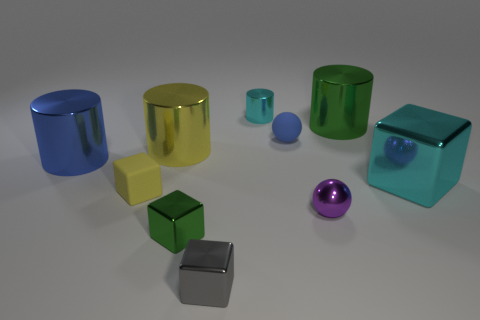Do the big blue thing and the green thing to the right of the cyan metal cylinder have the same material?
Make the answer very short. Yes. Are there more blue things right of the large cyan block than small blue matte balls that are on the right side of the blue rubber ball?
Keep it short and to the point. No. There is a tiny yellow object; what shape is it?
Make the answer very short. Cube. Is the blue object on the right side of the yellow matte block made of the same material as the green object to the left of the big green metallic cylinder?
Your answer should be compact. No. There is a blue object left of the tiny blue matte ball; what shape is it?
Ensure brevity in your answer.  Cylinder. The blue rubber thing that is the same shape as the purple metal object is what size?
Your response must be concise. Small. Is the color of the small cylinder the same as the big metallic cube?
Provide a short and direct response. Yes. There is a matte sphere to the left of the tiny purple metallic sphere; is there a cylinder in front of it?
Offer a terse response. Yes. What color is the large shiny object that is the same shape as the yellow matte object?
Keep it short and to the point. Cyan. How many metallic cylinders are the same color as the tiny matte block?
Offer a terse response. 1. 